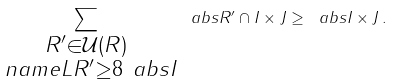Convert formula to latex. <formula><loc_0><loc_0><loc_500><loc_500>\sum _ { \substack { R ^ { \prime } \in \mathcal { U } ( R ) \\ \ n a m e L { R ^ { \prime } } \geq 8 \ a b s I } } \ a b s { R ^ { \prime } \cap I \times J } \geq \ a b s { I \times J } \, .</formula> 